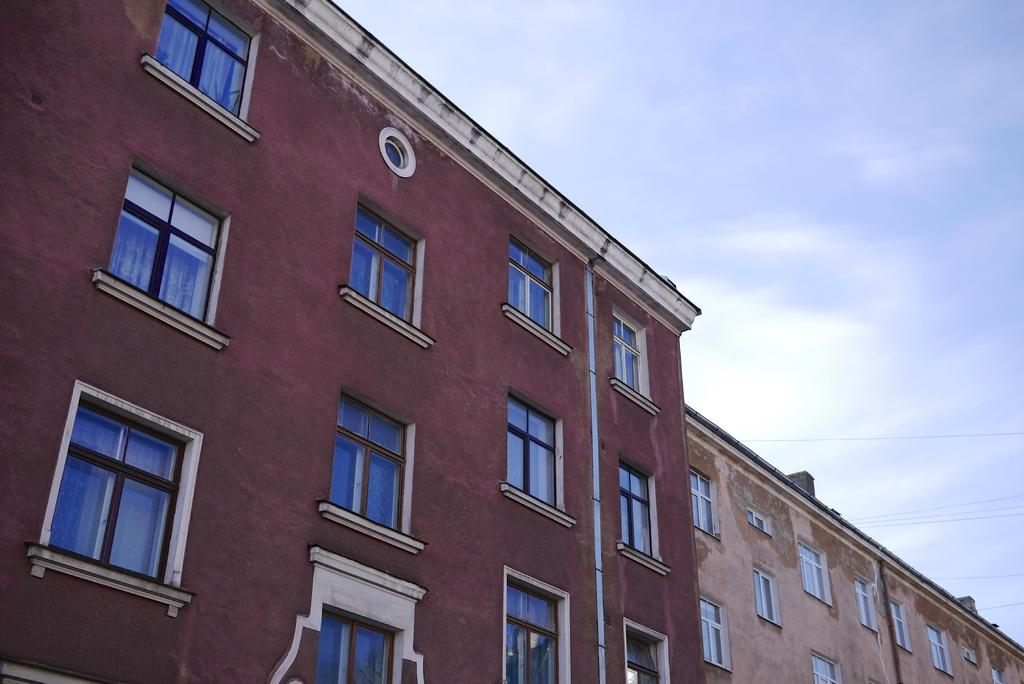What type of structures can be seen in the image? There are buildings in the image. What is visible at the top of the image? The sky is visible at the top of the image. What type of behavior can be observed in the jelly in the image? There is no jelly present in the image, so no behavior can be observed. 